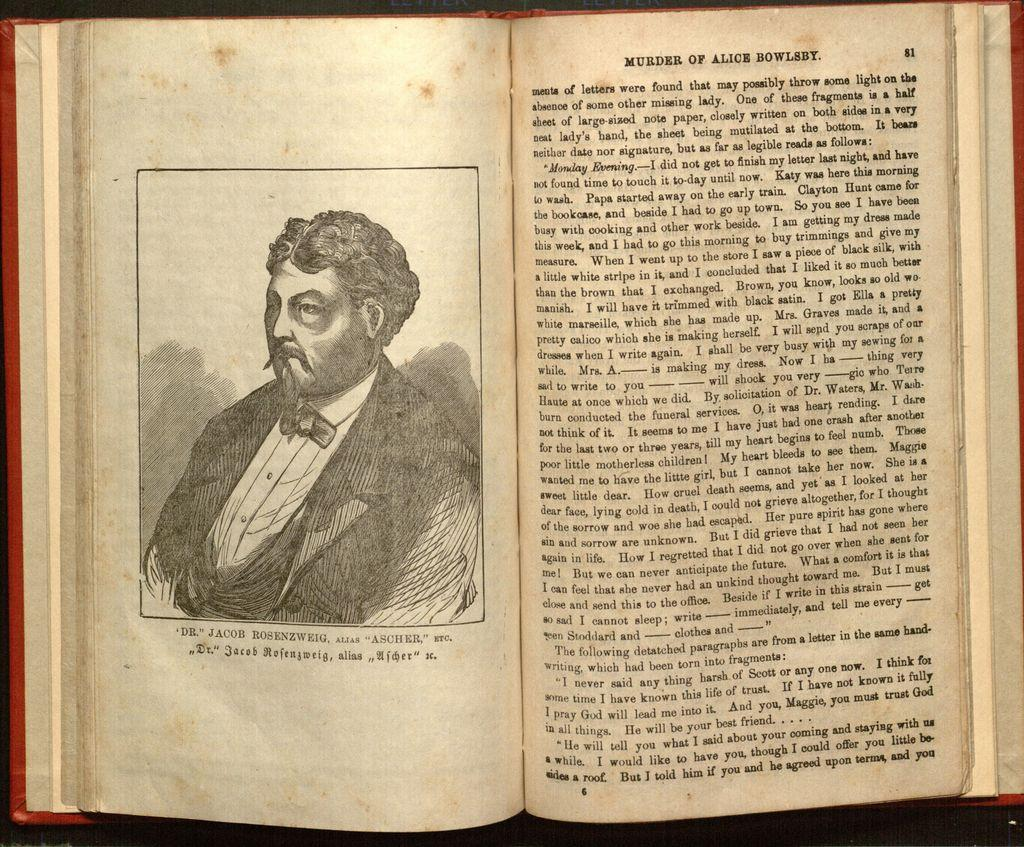<image>
Write a terse but informative summary of the picture. A book open to page 81 from murder of alice bowlsby 